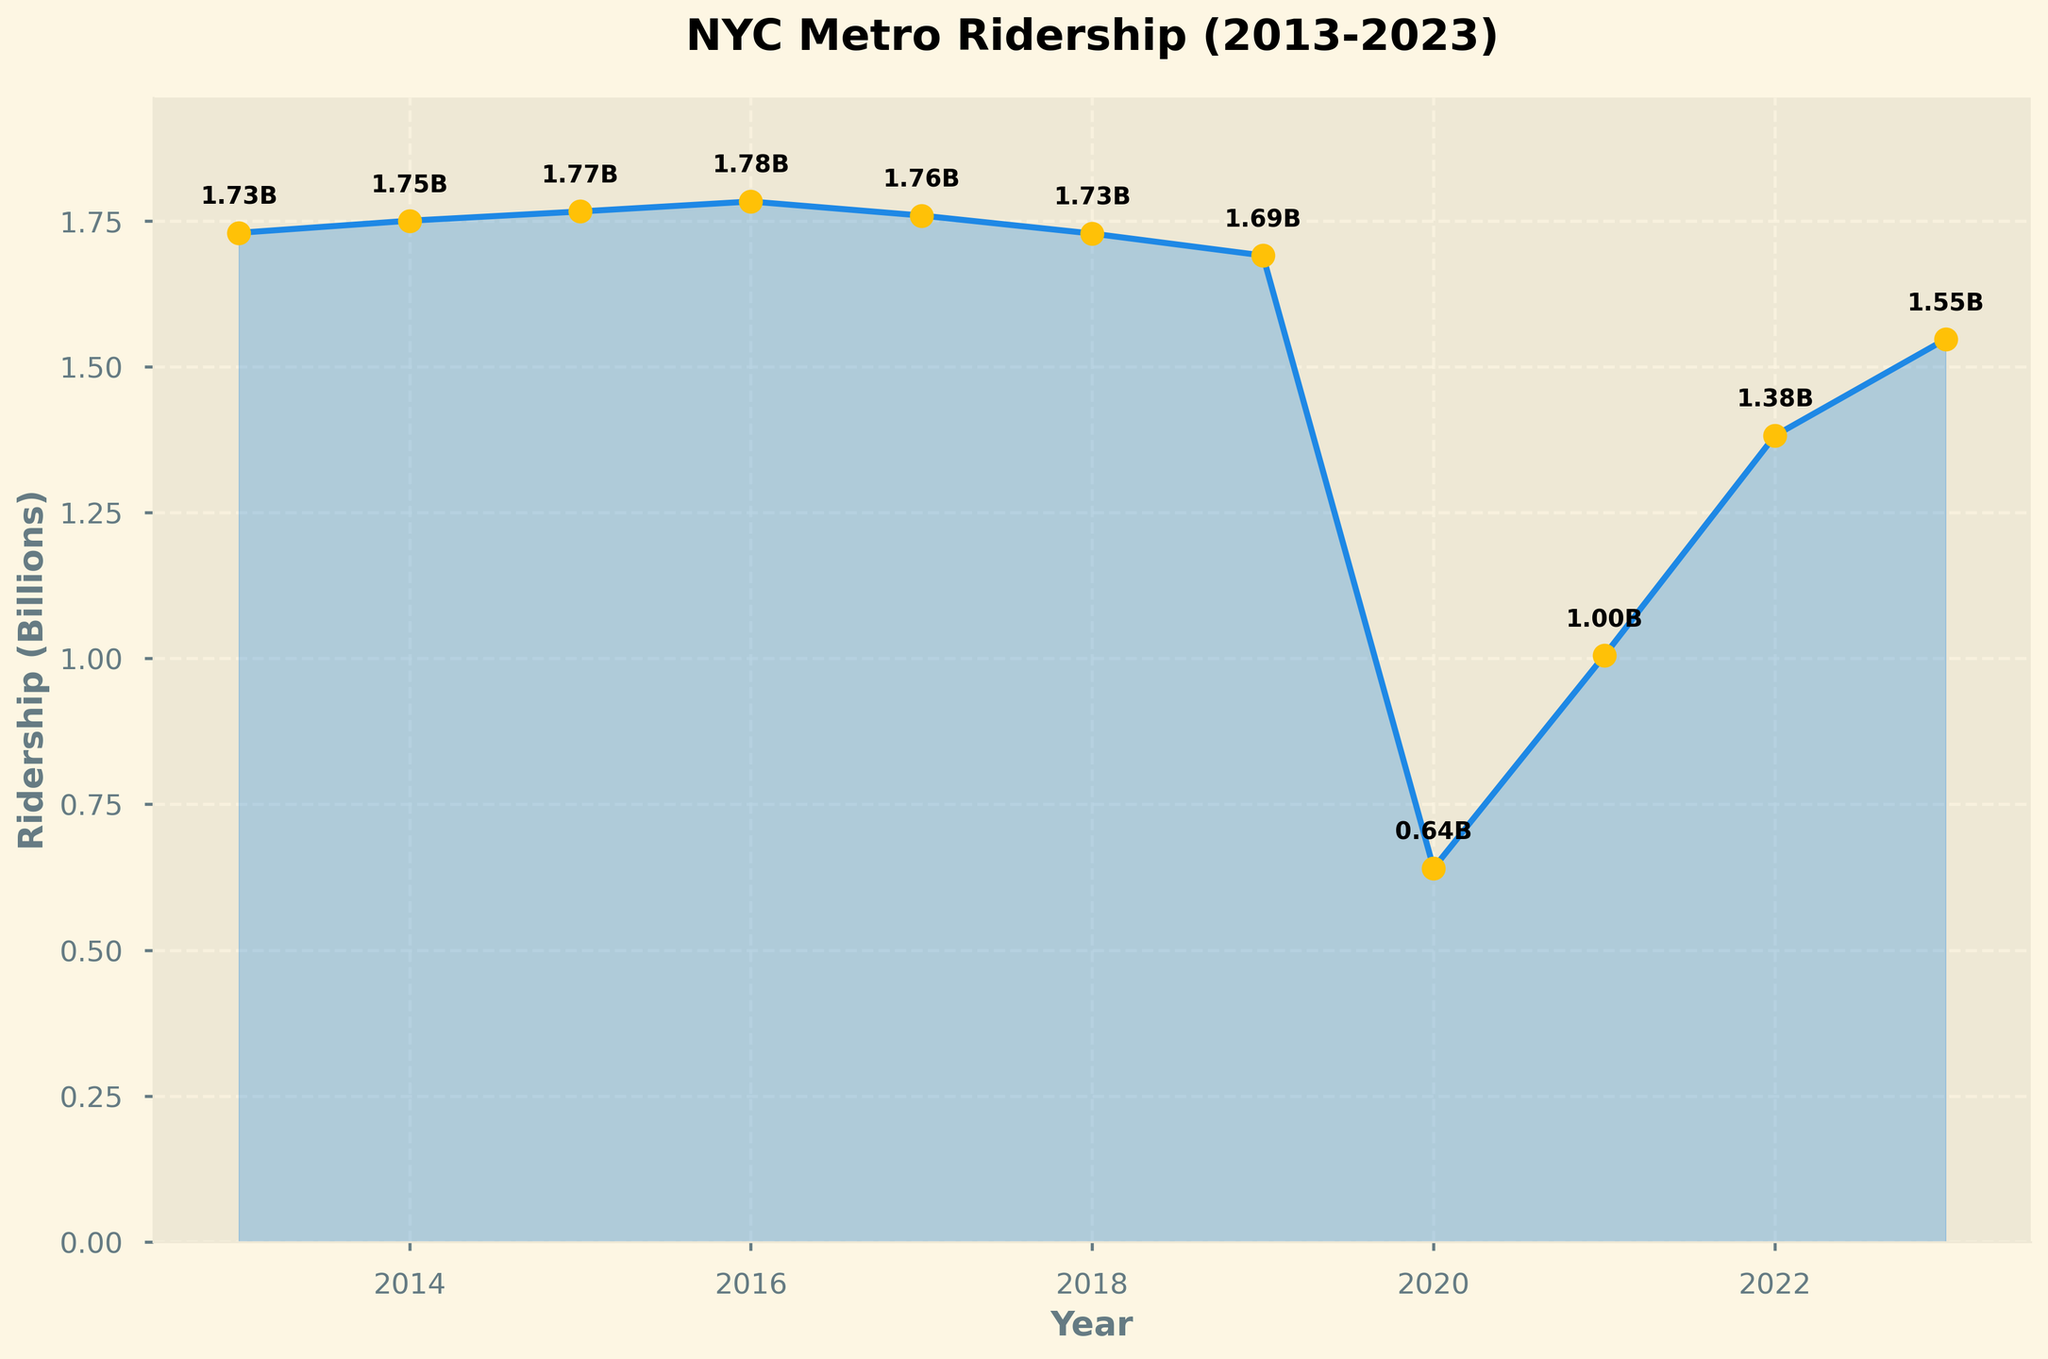What's the title of the plot? The plot's title is prominently displayed at the top of the figure.
Answer: NYC Metro Ridership (2013-2023) What is the ridership in 2016? The ridership for each year is labeled next to the points on the line. For 2016, the label reads 1.78B.
Answer: 1.78 billion How does the ridership in 2020 compare to the ridership in 2019? By looking at the plot, you can see a sharp decline from 2019 to 2020. The ridership values show that it dropped from 1.69B in 2019 to 0.64B in 2020.
Answer: It decreased What is the average ridership between 2013 to 2019 (excluding 2020)? Sum the ridership values from 2013 to 2019 and divide by the number of years (7). (1.73 + 1.75 + 1.77 + 1.78 + 1.76 + 1.73 + 1.69)/7 = 1.74B.
Answer: 1.74 billion In which year did ridership see the largest drop? By observing the plot, it is evident that the largest drop occurred between 2019 and 2020, where ridership fell sharply from 1.69B to 0.64B.
Answer: 2020 How much did ridership increase from 2020 to 2021? Subtract the ridership in 2020 from that in 2021. 1.00B - 0.64B = 0.36B.
Answer: 0.36 billion Which year had the lowest ridership and how much was it? The lowest point on the plot appears in 2020 with a ridership of 0.64B.
Answer: 2020, 0.64 billion What is the trend of ridership from 2021 to 2023? Observing the plot, there is a clear upward trend with ridership increasing from 1.00B in 2021 to 1.38B in 2022 and further to 1.55B in 2023.
Answer: Increasing Calculate the total ridership from 2013 to 2023. Add the ridership values for each year from 2013 to 2023. (1.73 + 1.75 + 1.77 + 1.78 + 1.76 + 1.73 + 1.69 + 0.64 + 1.00 + 1.38 + 1.55) = 16.78 billion.
Answer: 16.78 billion 